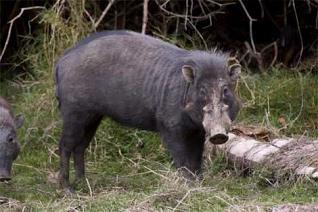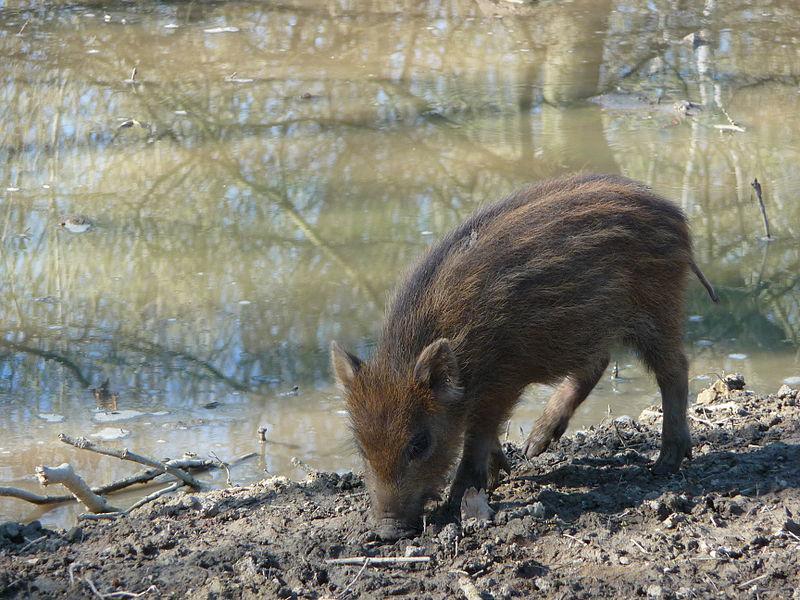The first image is the image on the left, the second image is the image on the right. For the images displayed, is the sentence "There are at least 9 wild boars in each set of images." factually correct? Answer yes or no. No. 